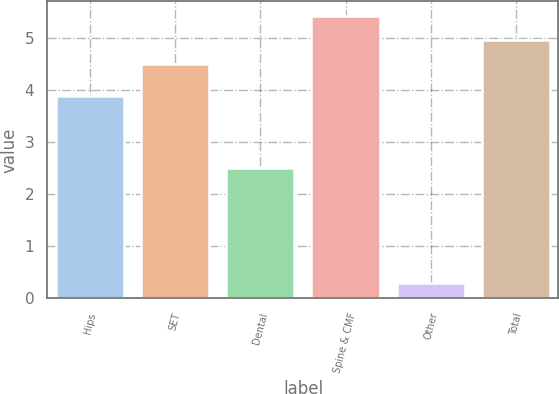Convert chart. <chart><loc_0><loc_0><loc_500><loc_500><bar_chart><fcel>Hips<fcel>SET<fcel>Dental<fcel>Spine & CMF<fcel>Other<fcel>Total<nl><fcel>3.9<fcel>4.5<fcel>2.5<fcel>5.44<fcel>0.3<fcel>4.97<nl></chart> 